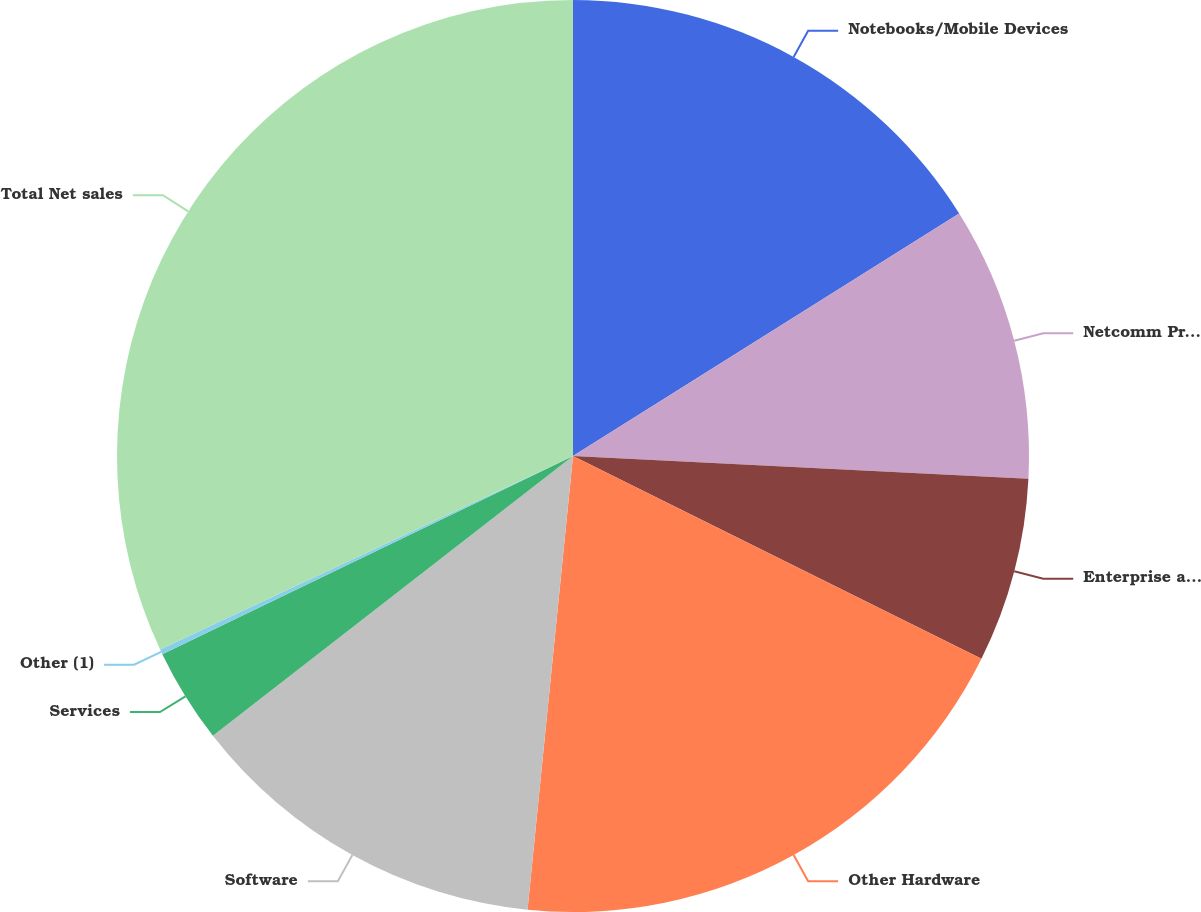Convert chart. <chart><loc_0><loc_0><loc_500><loc_500><pie_chart><fcel>Notebooks/Mobile Devices<fcel>Netcomm Products<fcel>Enterprise and Data Storage<fcel>Other Hardware<fcel>Software<fcel>Services<fcel>Other (1)<fcel>Total Net sales<nl><fcel>16.08%<fcel>9.72%<fcel>6.54%<fcel>19.26%<fcel>12.9%<fcel>3.36%<fcel>0.18%<fcel>31.98%<nl></chart> 